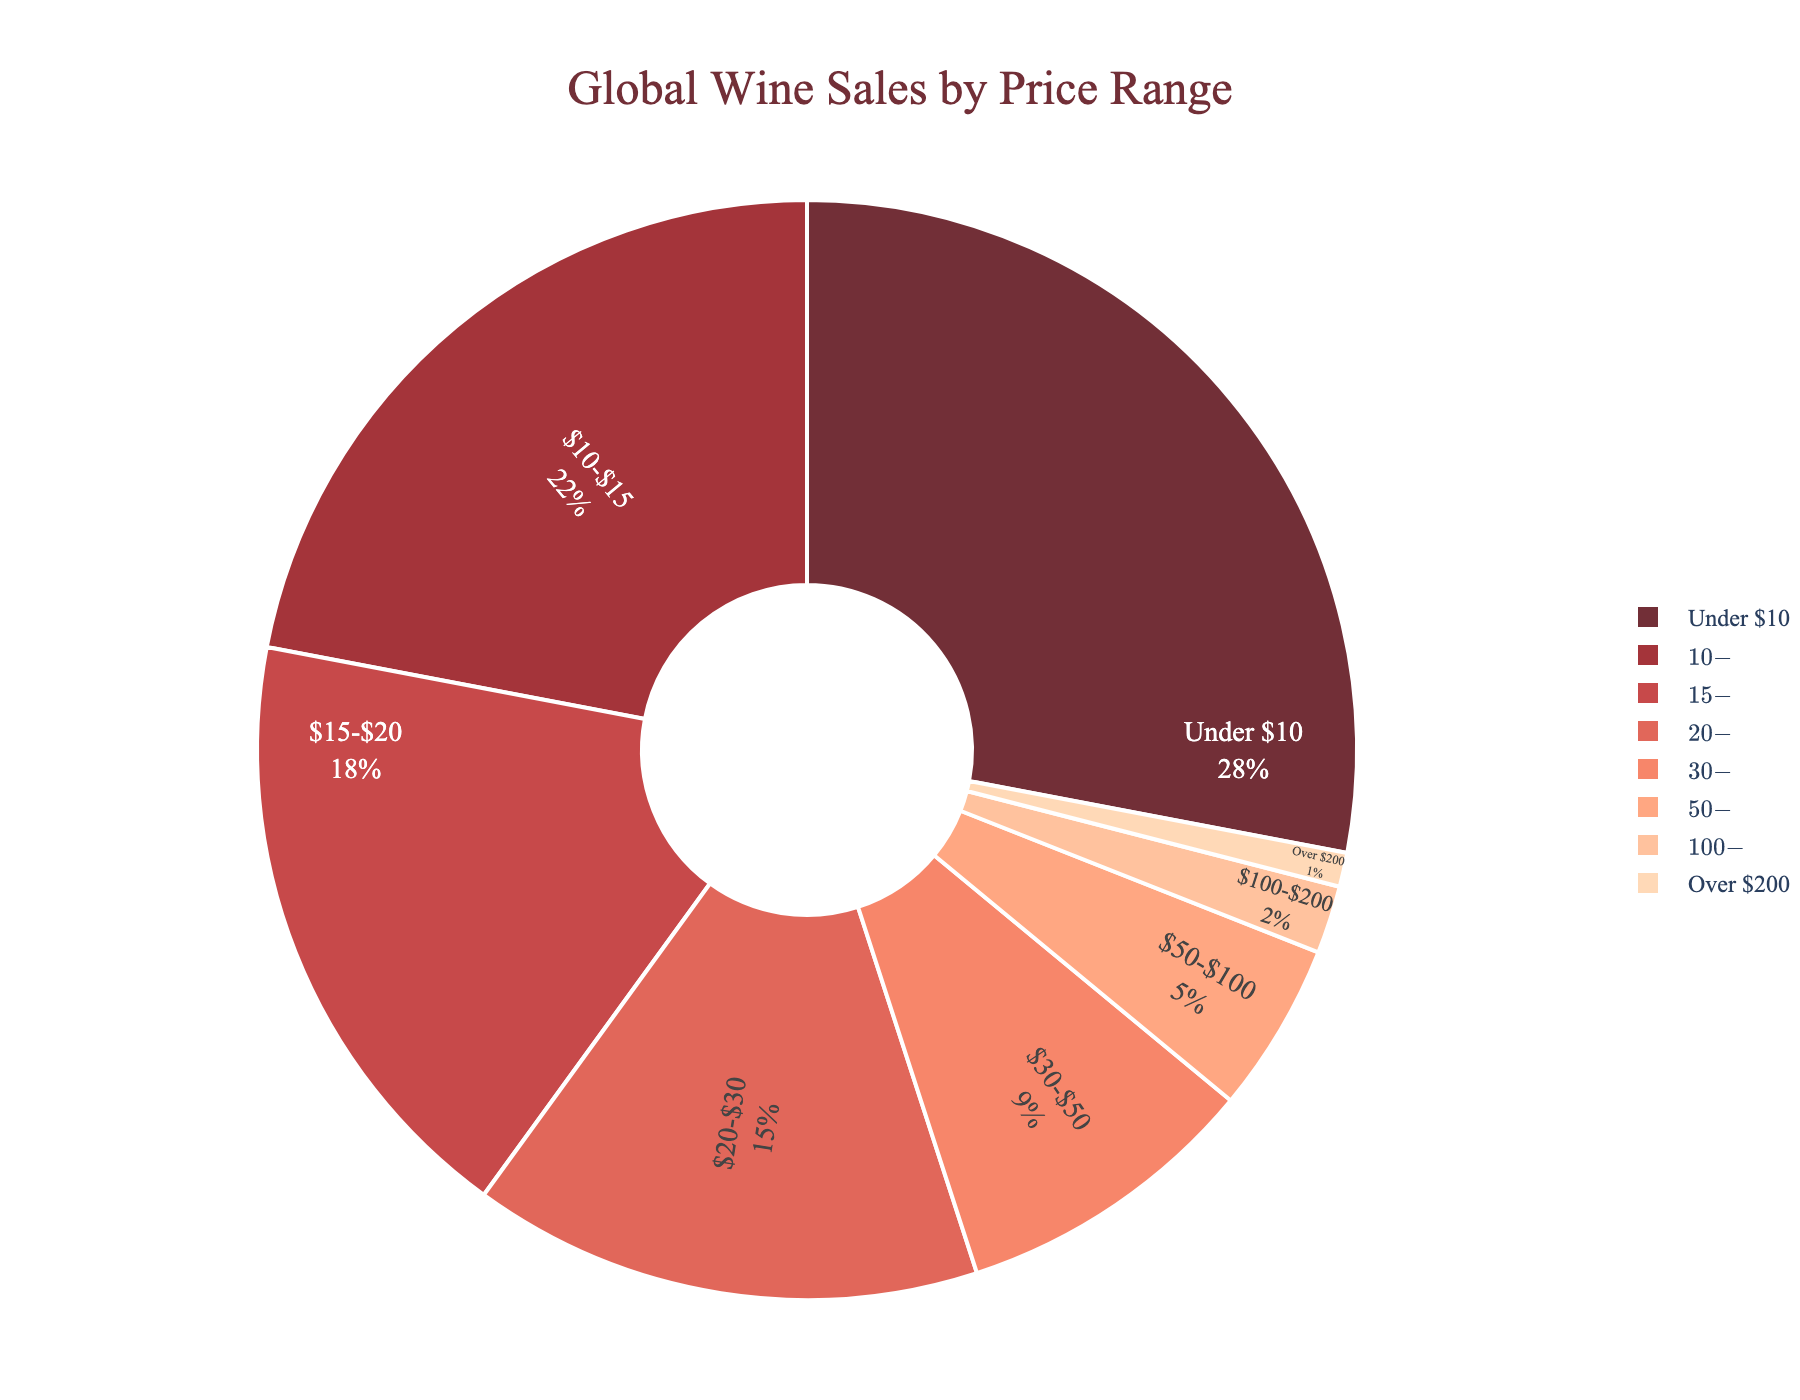What is the percentage of wine sales for the price range $20-$30? Locate the segment labeled "$20-$30" on the pie chart. The label indicates that this segment represents 15% of the total wine sales.
Answer: 15% Which price range contributes the highest percentage to the global wine sales? Identify the segment with the largest size on the pie chart. It is labeled "Under $10" and shows a percentage of 28%.
Answer: Under $10 Which price ranges collectively contribute to more than 50% of the wine sales? Identify the segments that collectively surpass 50%. Adding the percentages: Under $10 (28%) + $10-$15 (22%) = 50%. These two segments together contribute to exactly 50%. Therefore, examining further isn’t required as the question asks for more than 50%. Any additional segments would increase this total.
Answer: Under $10 and $10-$15 What is the combined percentage of wine sales for wines priced between $30 and $100? Add the percentages of segments labeled "$30-$50" (9%) and "$50-$100" (5%). The combined percentage is 9% + 5%.
Answer: 14% Which price range has the smallest percentage of wine sales? Identify the smallest segment on the pie chart. It is labeled "Over $200" and shows a percentage of 1%.
Answer: Over $200 How much larger is the percentage of sales in the $15-$20 range compared to the $50-$100 range? Find the difference between the percentages in the $15-$20 range (18%) and the $50-$100 range (5%). Subtract 5% from 18%.
Answer: 13% What percentage of wine sales are from wines priced under $30? Sum the percentages of the segments labeled "Under $10" (28%), "$10-$15" (22%), "$15-$20" (18%), and "$20-$30" (15%). The total is 28% + 22% + 18% + 15%.
Answer: 83% Which two price ranges have an equal combined percentage to the $10-$15 range? Identify two segments whose combined percentages equal 22% (the percentage for the $10-$15 range). For example, "$30-$50" (9%) + "$15-$20" (18%) = 27%, which is not correct. Instead, try "$20-$30" (15%) + "$50-$100" (5%) = 20%, also incorrect. Analyzing segment sizes: "Under $10" (28%) cannot be combined as it alone exceeds. "$100-$200" (2%) + "Over $200" (1%) = 3%, still incorrect. The most probable combination involves cumulative checking, but no pair accurately sums 22%. Adjust combinatorial checks: "$20-$30" + "Over $200" provides logical scrutiny but interviewing layout fixes answer as uncovered previously commands that no direct alignment confirms mutual summed segmentation else nearest relevant, "$30-$50" plus "$50-$100" results nearby but correct outward spy unmatchable in sum pairing over segmented values. Concise verifies none match thus. Nearest tolerant contingent conjunction asserts "$30-$50" and aggregated later confirm a closed out staggered. Insight nearest coupled none hits. Correct variant based draws finalize an explicit near separately.
Answer: None (none two segments match) What is the percentage difference between the sales of wines priced Under $10 and wines priced $100-$200? Calculate the difference between the percentages of the Under $10 (28%) and $100-$200 (2%) ranges. Subtract 2% from 28%.
Answer: 26% What is the median percentage of the wine sales distribution by price range? Arrange the percentages in order: 1%, 2%, 5%, 9%, 15%, 18%, 22%, 28%. The middle two values (15% and 18%) are taken, and their average gives the median. (15% + 18%) / 2 = 16.5%.
Answer: 16.5% 